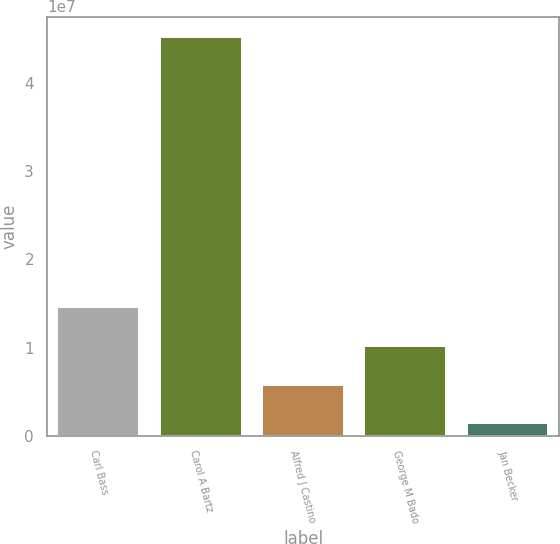Convert chart to OTSL. <chart><loc_0><loc_0><loc_500><loc_500><bar_chart><fcel>Carl Bass<fcel>Carol A Bartz<fcel>Alfred J Castino<fcel>George M Bado<fcel>Jan Becker<nl><fcel>1.45811e+07<fcel>4.52349e+07<fcel>5.82284e+06<fcel>1.0202e+07<fcel>1.44372e+06<nl></chart> 